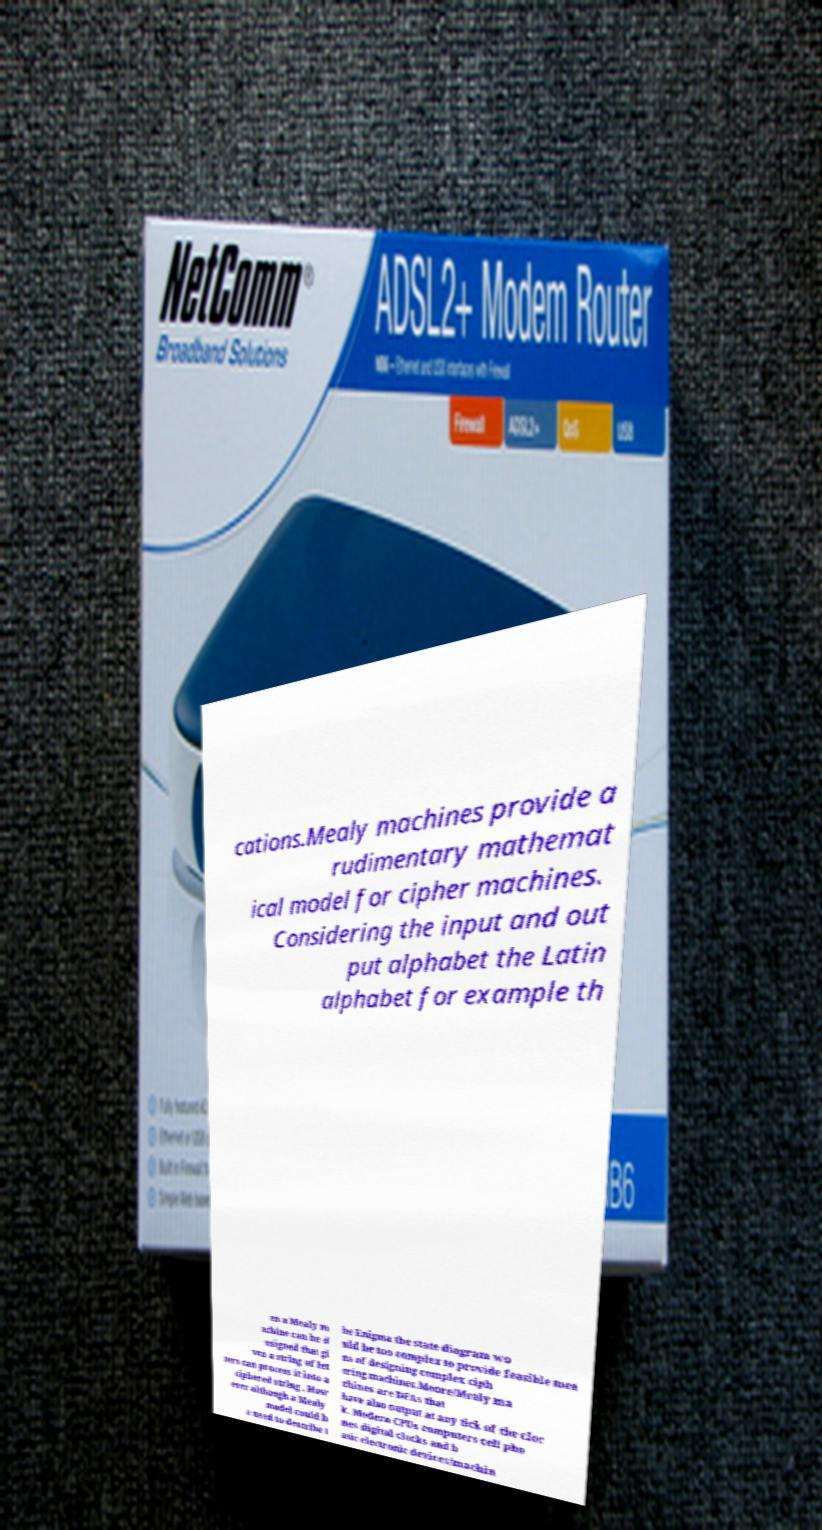Please identify and transcribe the text found in this image. cations.Mealy machines provide a rudimentary mathemat ical model for cipher machines. Considering the input and out put alphabet the Latin alphabet for example th en a Mealy m achine can be d esigned that gi ven a string of let ters can process it into a ciphered string . How ever although a Mealy model could b e used to describe t he Enigma the state diagram wo uld be too complex to provide feasible mea ns of designing complex ciph ering machines.Moore/Mealy ma chines are DFAs that have also output at any tick of the cloc k. Modern CPUs computers cell pho nes digital clocks and b asic electronic devices/machin 